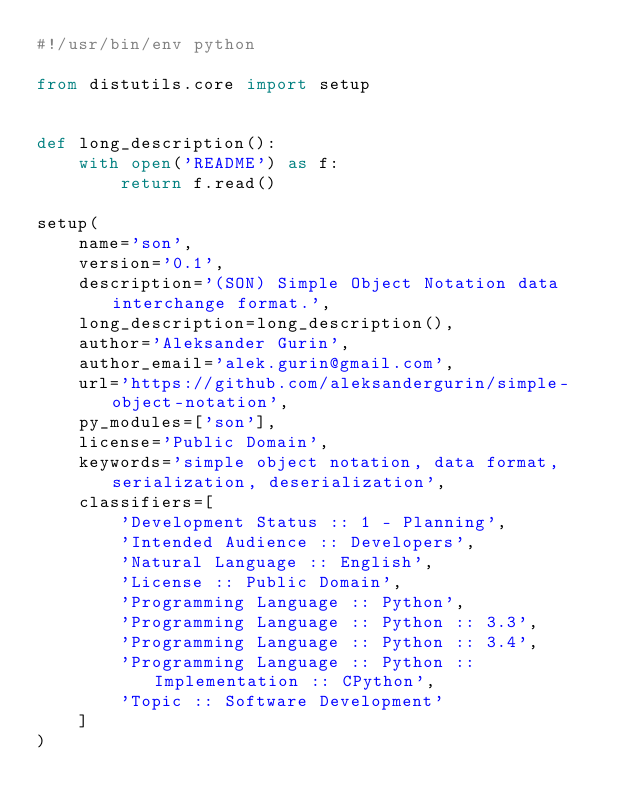<code> <loc_0><loc_0><loc_500><loc_500><_Python_>#!/usr/bin/env python

from distutils.core import setup


def long_description():
    with open('README') as f:
        return f.read()

setup(
    name='son',
    version='0.1',
    description='(SON) Simple Object Notation data interchange format.',
    long_description=long_description(),
    author='Aleksander Gurin',
    author_email='alek.gurin@gmail.com',
    url='https://github.com/aleksandergurin/simple-object-notation',
    py_modules=['son'],
    license='Public Domain',
    keywords='simple object notation, data format, serialization, deserialization',
    classifiers=[
        'Development Status :: 1 - Planning',
        'Intended Audience :: Developers',
        'Natural Language :: English',
        'License :: Public Domain',
        'Programming Language :: Python',
        'Programming Language :: Python :: 3.3',
        'Programming Language :: Python :: 3.4',
        'Programming Language :: Python :: Implementation :: CPython',
        'Topic :: Software Development'
    ]
)
</code> 